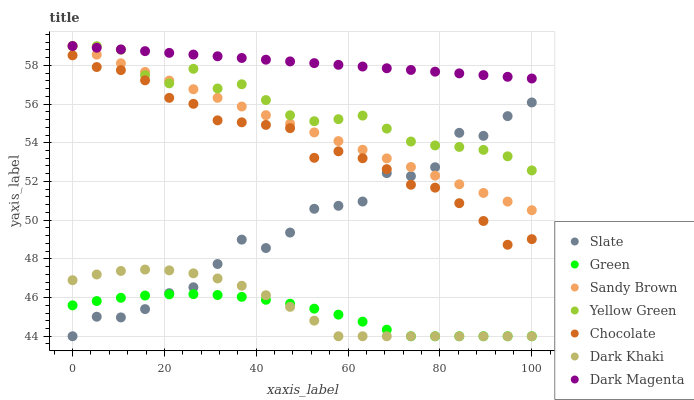Does Green have the minimum area under the curve?
Answer yes or no. Yes. Does Dark Magenta have the maximum area under the curve?
Answer yes or no. Yes. Does Slate have the minimum area under the curve?
Answer yes or no. No. Does Slate have the maximum area under the curve?
Answer yes or no. No. Is Dark Magenta the smoothest?
Answer yes or no. Yes. Is Slate the roughest?
Answer yes or no. Yes. Is Chocolate the smoothest?
Answer yes or no. No. Is Chocolate the roughest?
Answer yes or no. No. Does Slate have the lowest value?
Answer yes or no. Yes. Does Chocolate have the lowest value?
Answer yes or no. No. Does Dark Magenta have the highest value?
Answer yes or no. Yes. Does Slate have the highest value?
Answer yes or no. No. Is Chocolate less than Yellow Green?
Answer yes or no. Yes. Is Yellow Green greater than Dark Khaki?
Answer yes or no. Yes. Does Chocolate intersect Slate?
Answer yes or no. Yes. Is Chocolate less than Slate?
Answer yes or no. No. Is Chocolate greater than Slate?
Answer yes or no. No. Does Chocolate intersect Yellow Green?
Answer yes or no. No. 